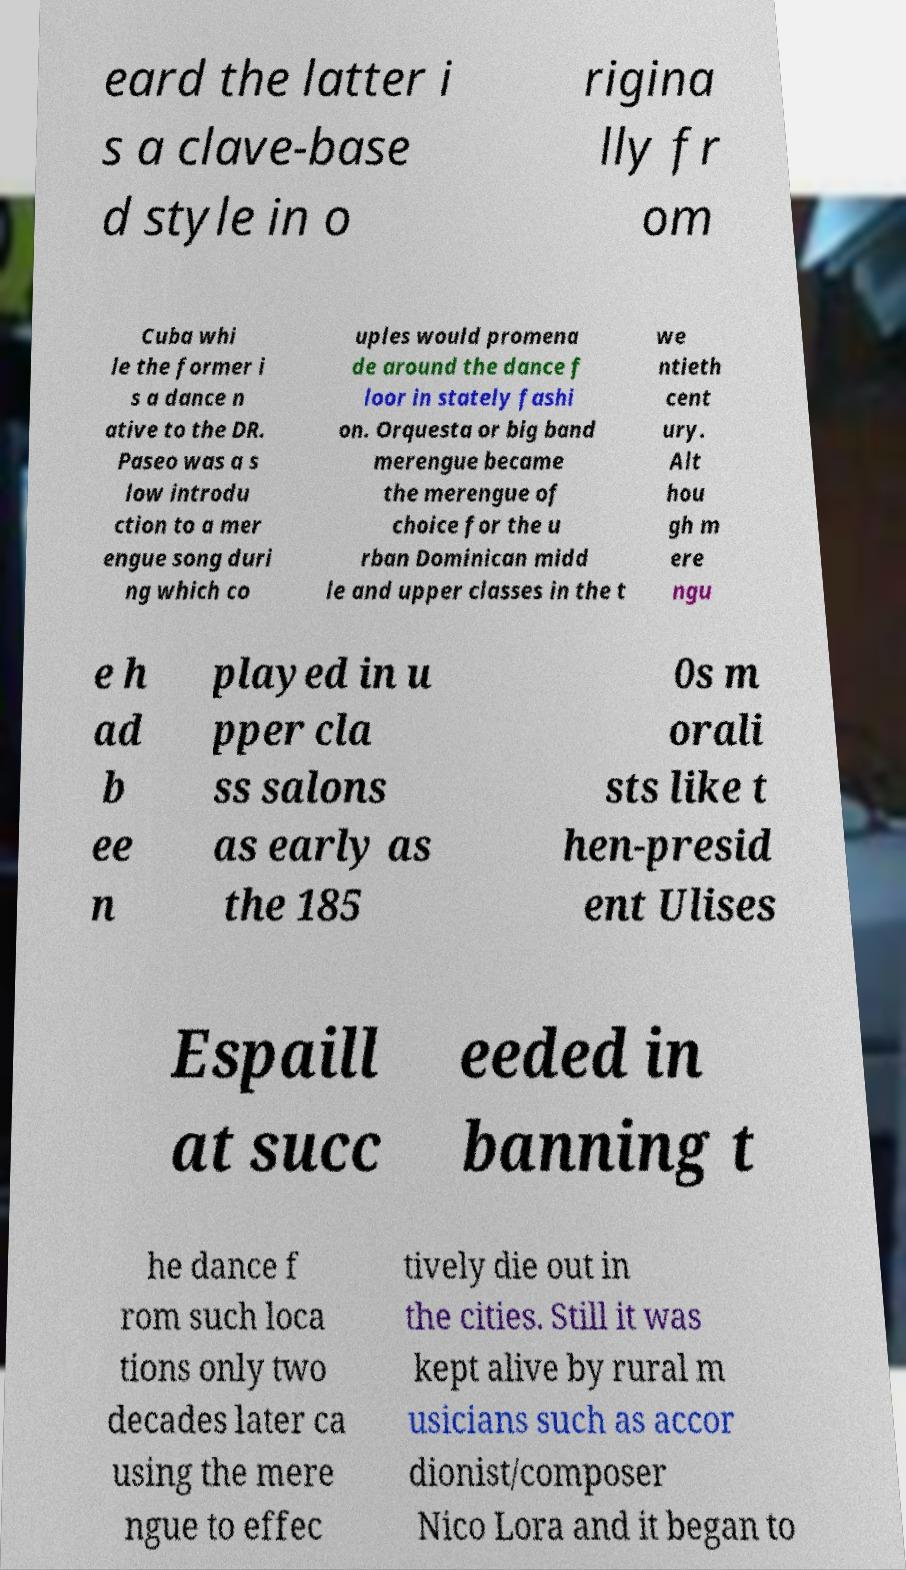For documentation purposes, I need the text within this image transcribed. Could you provide that? eard the latter i s a clave-base d style in o rigina lly fr om Cuba whi le the former i s a dance n ative to the DR. Paseo was a s low introdu ction to a mer engue song duri ng which co uples would promena de around the dance f loor in stately fashi on. Orquesta or big band merengue became the merengue of choice for the u rban Dominican midd le and upper classes in the t we ntieth cent ury. Alt hou gh m ere ngu e h ad b ee n played in u pper cla ss salons as early as the 185 0s m orali sts like t hen-presid ent Ulises Espaill at succ eeded in banning t he dance f rom such loca tions only two decades later ca using the mere ngue to effec tively die out in the cities. Still it was kept alive by rural m usicians such as accor dionist/composer Nico Lora and it began to 